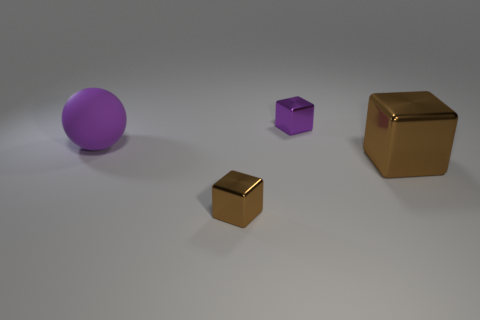Is the size of the metallic thing that is in front of the large brown shiny thing the same as the brown block that is behind the small brown metal thing?
Make the answer very short. No. How many other things are made of the same material as the big block?
Give a very brief answer. 2. Is the number of large metallic objects that are left of the small purple object greater than the number of purple blocks that are right of the large metallic thing?
Ensure brevity in your answer.  No. There is a small cube that is behind the tiny brown shiny thing; what material is it?
Your answer should be compact. Metal. Is the tiny purple metallic thing the same shape as the tiny brown thing?
Your response must be concise. Yes. Is there any other thing that is the same color as the large block?
Provide a short and direct response. Yes. What color is the large metallic thing that is the same shape as the tiny brown thing?
Offer a very short reply. Brown. Are there more metallic things in front of the large brown metal object than red rubber cubes?
Give a very brief answer. Yes. There is a small cube behind the large matte ball; what color is it?
Give a very brief answer. Purple. Is the purple ball the same size as the purple metal thing?
Keep it short and to the point. No. 